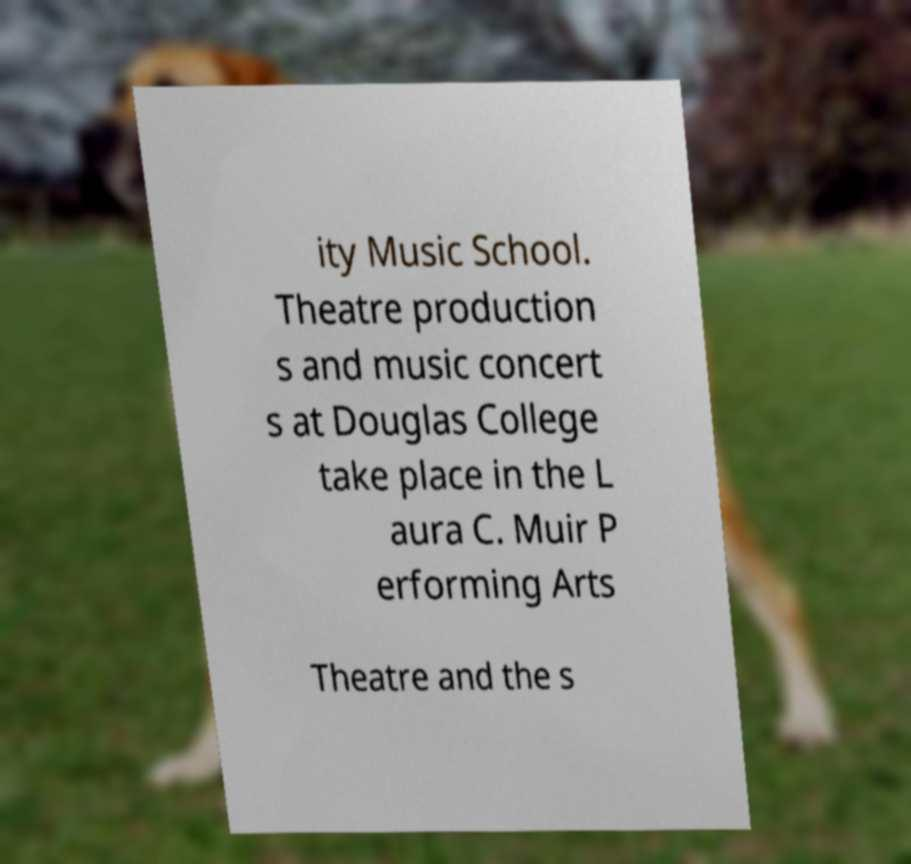For documentation purposes, I need the text within this image transcribed. Could you provide that? ity Music School. Theatre production s and music concert s at Douglas College take place in the L aura C. Muir P erforming Arts Theatre and the s 